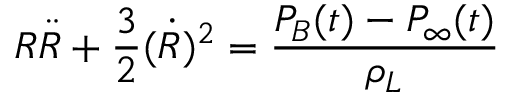<formula> <loc_0><loc_0><loc_500><loc_500>R \ddot { R } + \frac { 3 } { 2 } ( \dot { R } ) ^ { 2 } = \frac { P _ { B } ( t ) - P _ { \infty } ( t ) } { \rho _ { L } }</formula> 